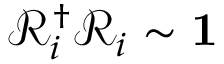Convert formula to latex. <formula><loc_0><loc_0><loc_500><loc_500>\mathcal { R } _ { i } ^ { \dagger } \mathcal { R } _ { i } \sim 1</formula> 